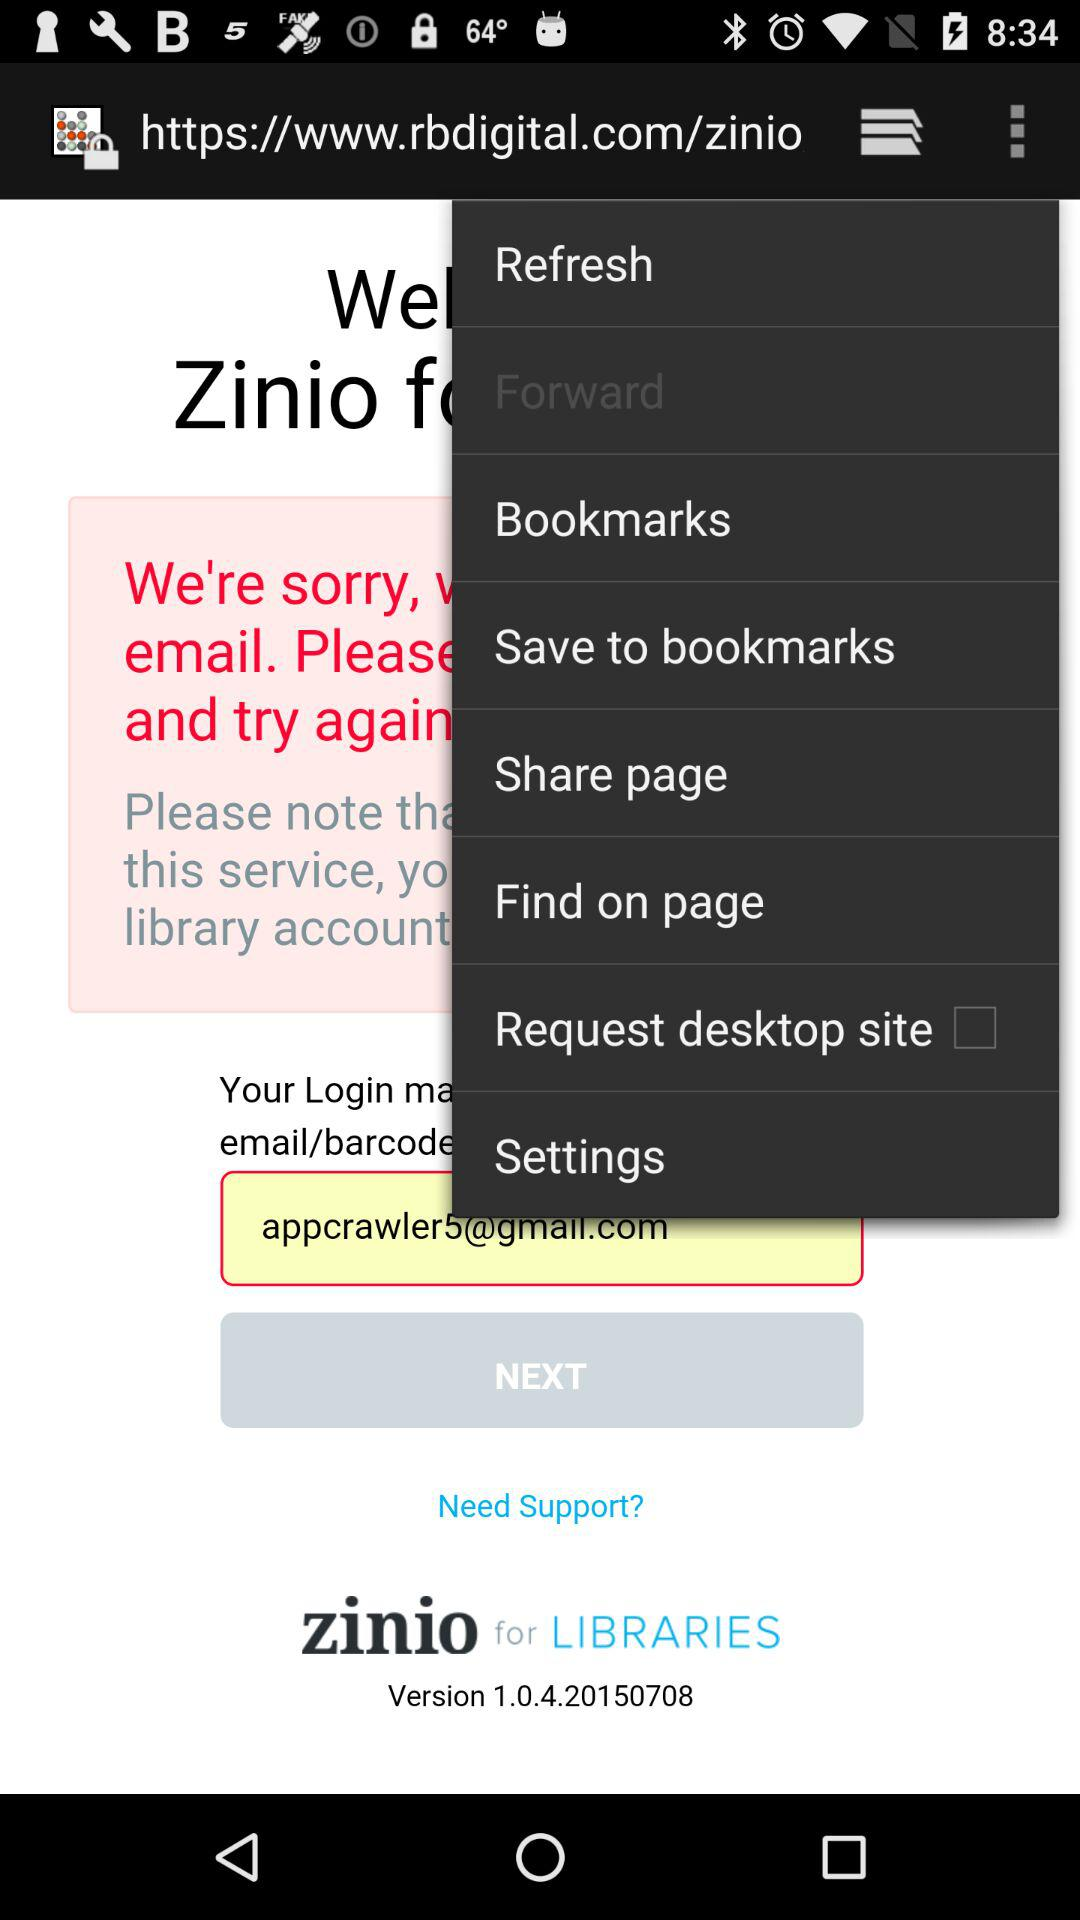What is the version of the application being used? The version of the application is 1.0.4.20150708. 